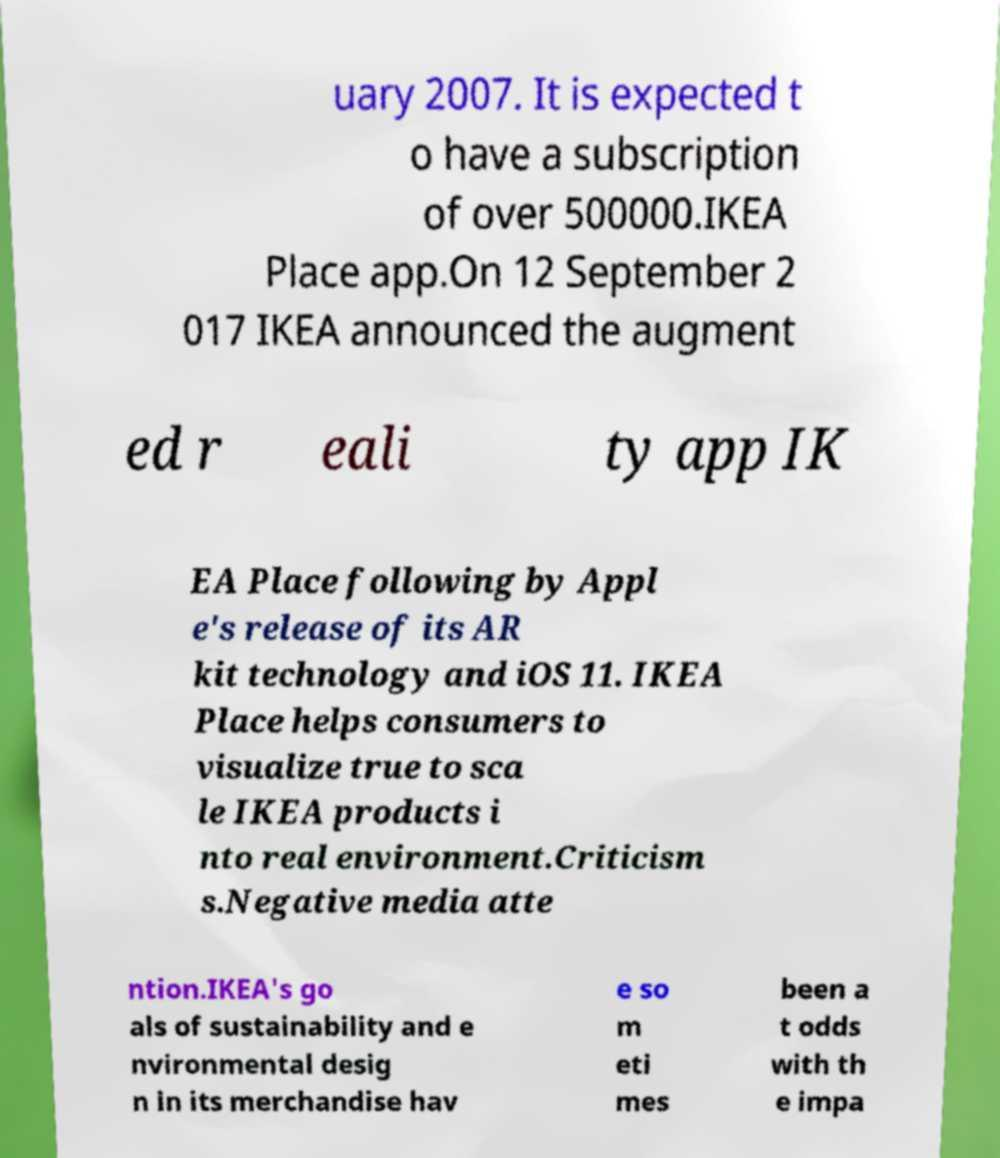What messages or text are displayed in this image? I need them in a readable, typed format. uary 2007. It is expected t o have a subscription of over 500000.IKEA Place app.On 12 September 2 017 IKEA announced the augment ed r eali ty app IK EA Place following by Appl e's release of its AR kit technology and iOS 11. IKEA Place helps consumers to visualize true to sca le IKEA products i nto real environment.Criticism s.Negative media atte ntion.IKEA's go als of sustainability and e nvironmental desig n in its merchandise hav e so m eti mes been a t odds with th e impa 